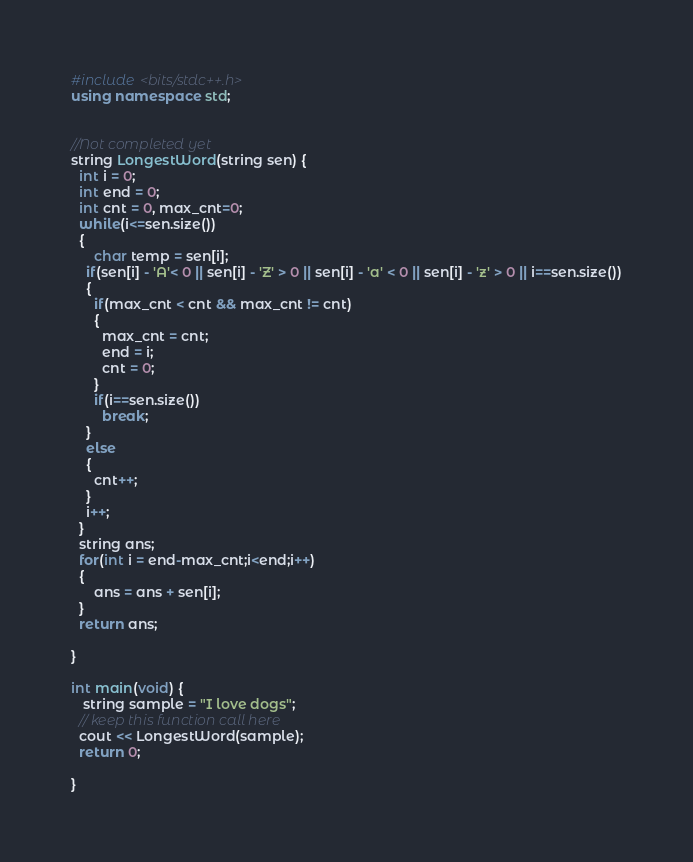Convert code to text. <code><loc_0><loc_0><loc_500><loc_500><_C++_>#include <bits/stdc++.h>
using namespace std;


//Not completed yet
string LongestWord(string sen) {
  int i = 0;
  int end = 0;
  int cnt = 0, max_cnt=0;
  while(i<=sen.size())
  {
      char temp = sen[i];
    if(sen[i] - 'A'< 0 || sen[i] - 'Z' > 0 || sen[i] - 'a' < 0 || sen[i] - 'z' > 0 || i==sen.size())
    {
      if(max_cnt < cnt && max_cnt != cnt)
      {
        max_cnt = cnt;
        end = i;
        cnt = 0;
      }
      if(i==sen.size())
        break;
    }
    else
    {
      cnt++;
    }
    i++;
  }
  string ans;
  for(int i = end-max_cnt;i<end;i++)
  {
      ans = ans + sen[i];
  }  
  return ans;

}

int main(void) { 
   string sample = "I love dogs";
  // keep this function call here
  cout << LongestWord(sample);
  return 0;
    
}</code> 